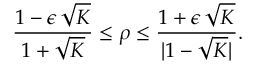Convert formula to latex. <formula><loc_0><loc_0><loc_500><loc_500>\frac { 1 - \epsilon \, \sqrt { K } } { 1 + \sqrt { K } } \leq \rho \leq \frac { 1 + \epsilon \, \sqrt { K } } { | 1 - \sqrt { K } | } .</formula> 